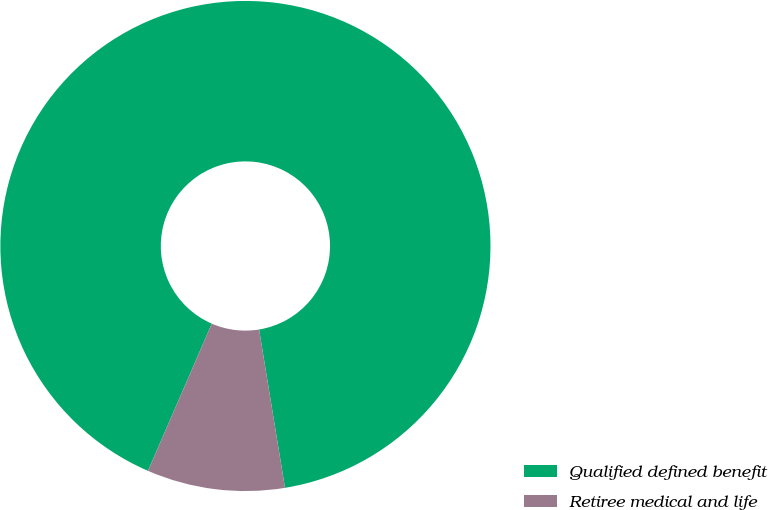<chart> <loc_0><loc_0><loc_500><loc_500><pie_chart><fcel>Qualified defined benefit<fcel>Retiree medical and life<nl><fcel>90.91%<fcel>9.09%<nl></chart> 